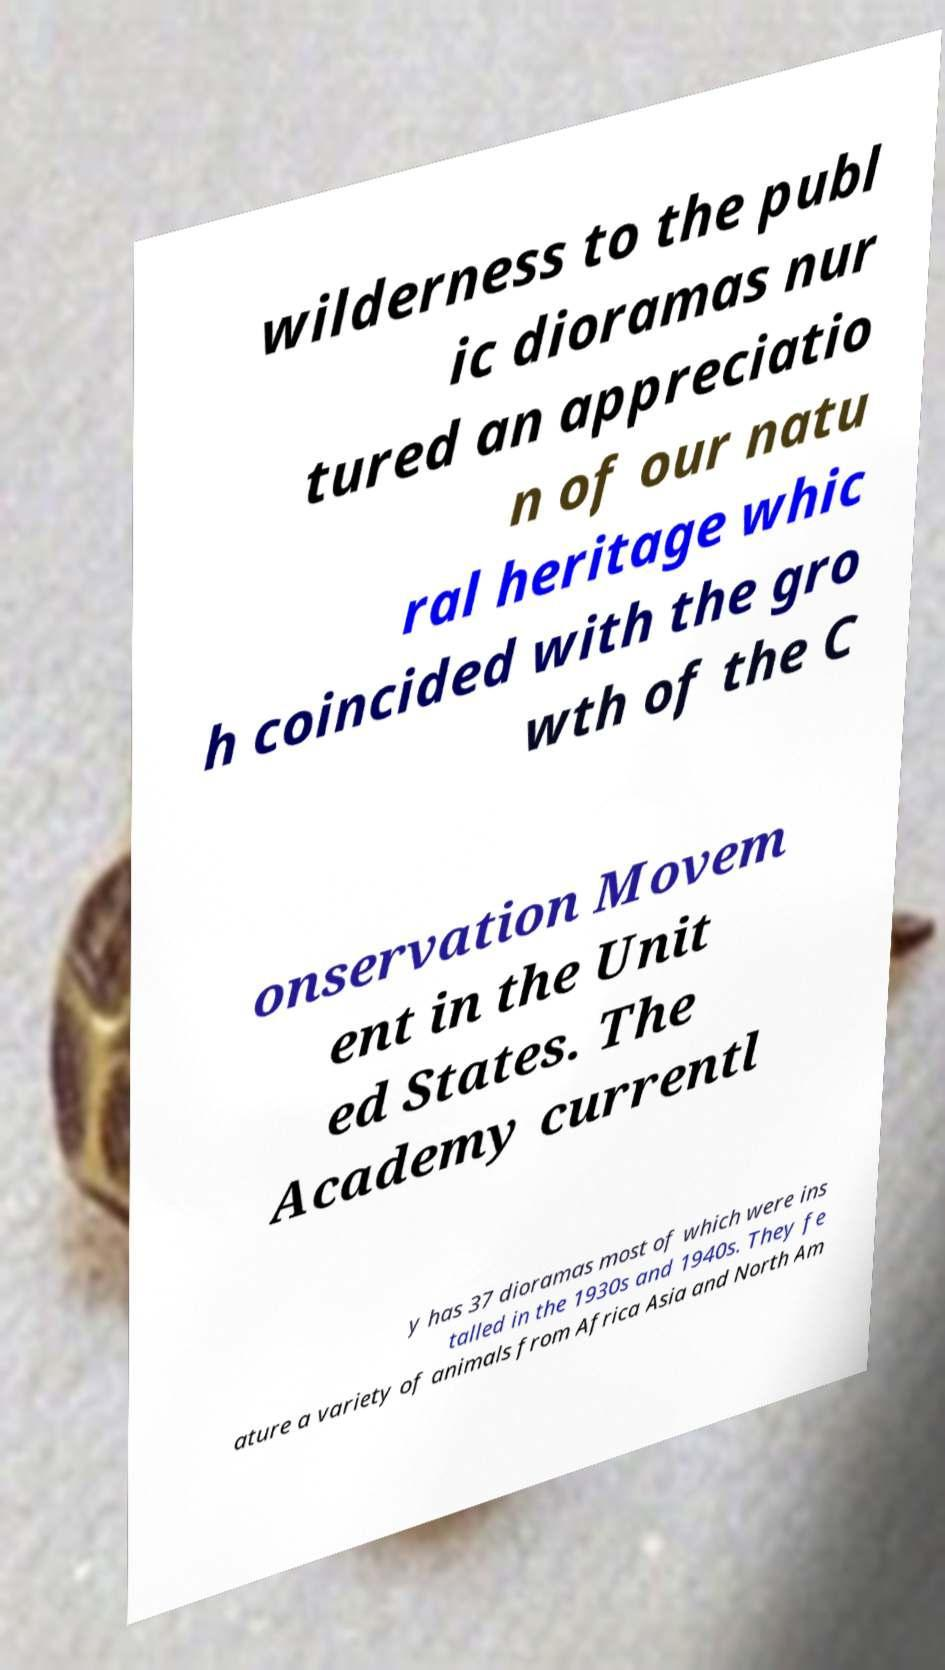Please read and relay the text visible in this image. What does it say? wilderness to the publ ic dioramas nur tured an appreciatio n of our natu ral heritage whic h coincided with the gro wth of the C onservation Movem ent in the Unit ed States. The Academy currentl y has 37 dioramas most of which were ins talled in the 1930s and 1940s. They fe ature a variety of animals from Africa Asia and North Am 